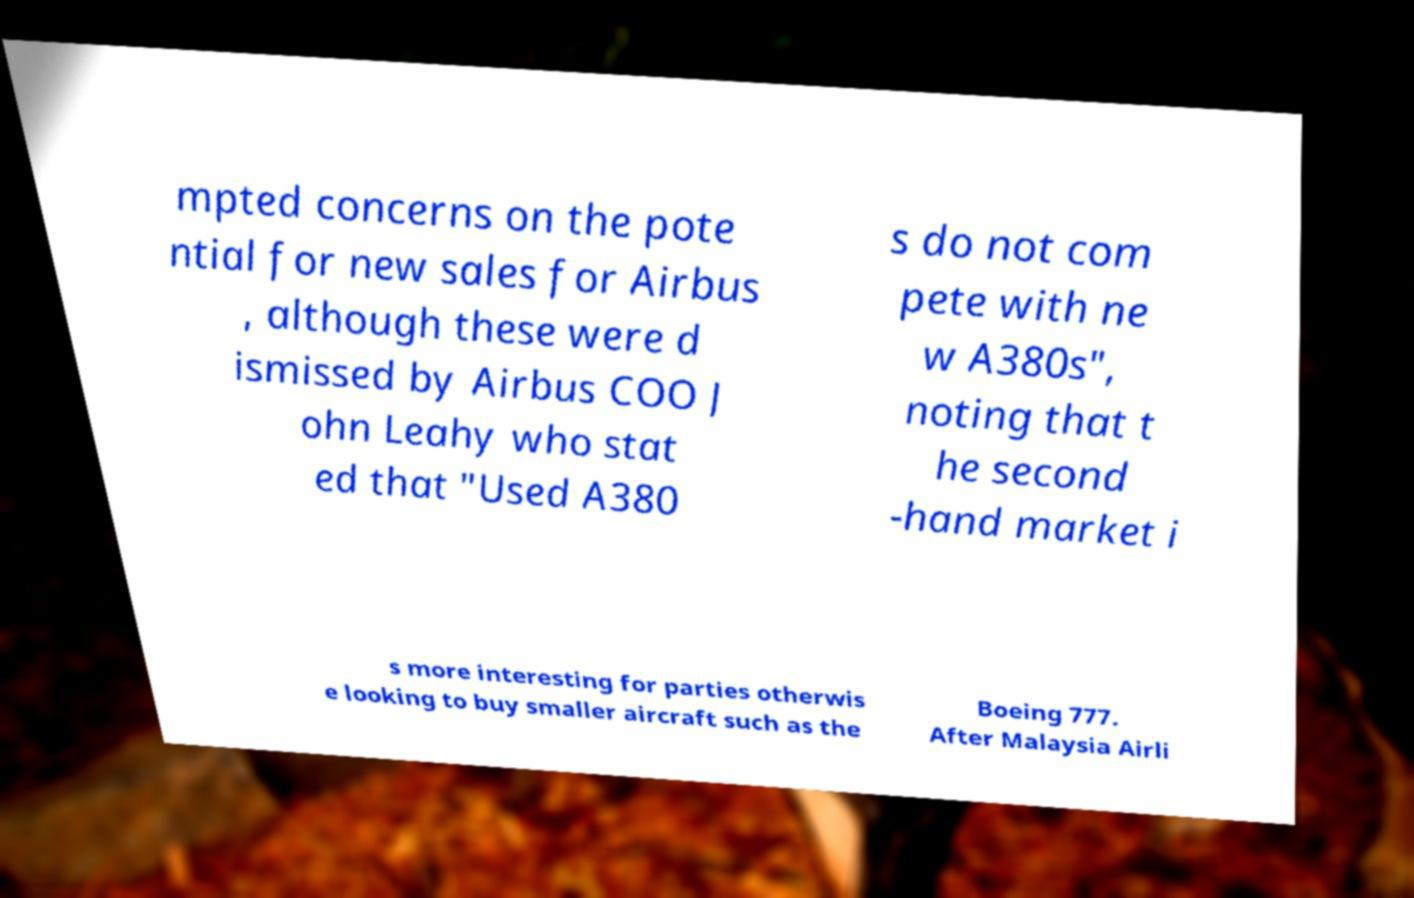What messages or text are displayed in this image? I need them in a readable, typed format. mpted concerns on the pote ntial for new sales for Airbus , although these were d ismissed by Airbus COO J ohn Leahy who stat ed that "Used A380 s do not com pete with ne w A380s", noting that t he second -hand market i s more interesting for parties otherwis e looking to buy smaller aircraft such as the Boeing 777. After Malaysia Airli 